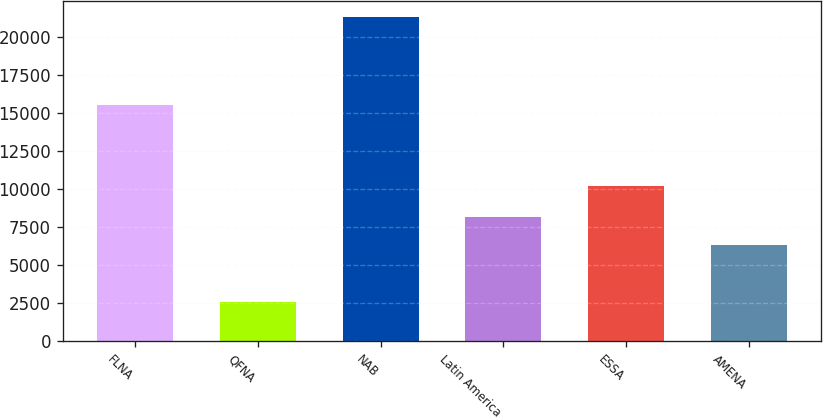Convert chart. <chart><loc_0><loc_0><loc_500><loc_500><bar_chart><fcel>FLNA<fcel>QFNA<fcel>NAB<fcel>Latin America<fcel>ESSA<fcel>AMENA<nl><fcel>15549<fcel>2564<fcel>21312<fcel>8212.8<fcel>10216<fcel>6338<nl></chart> 